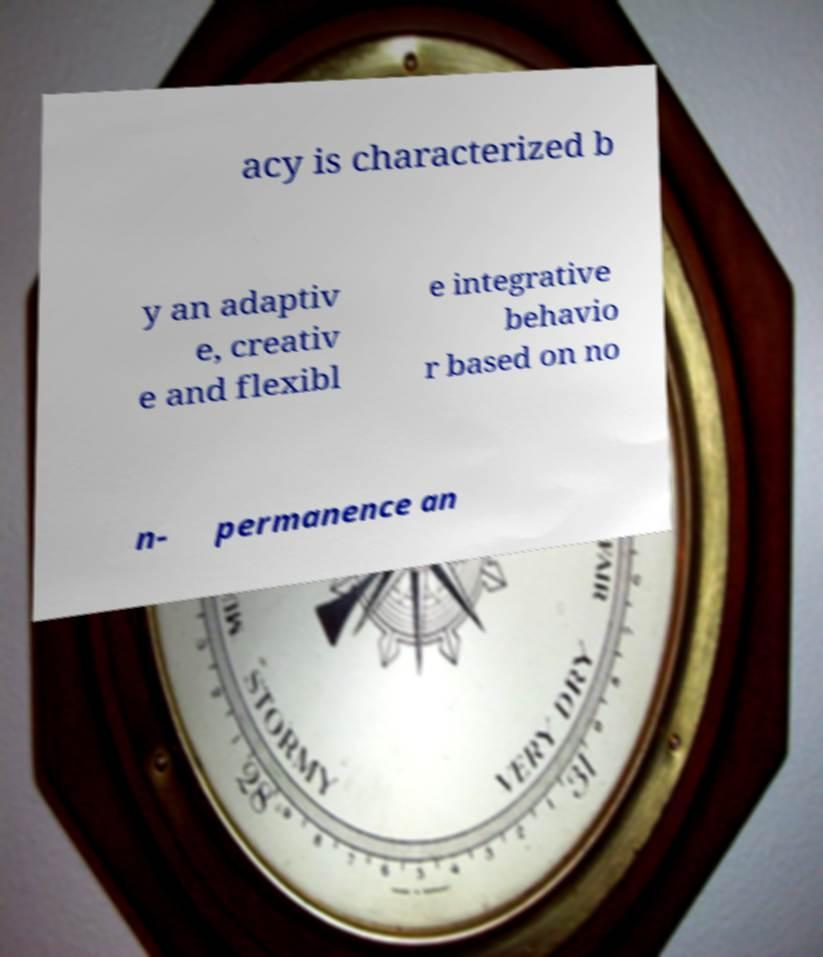Could you extract and type out the text from this image? acy is characterized b y an adaptiv e, creativ e and flexibl e integrative behavio r based on no n- permanence an 